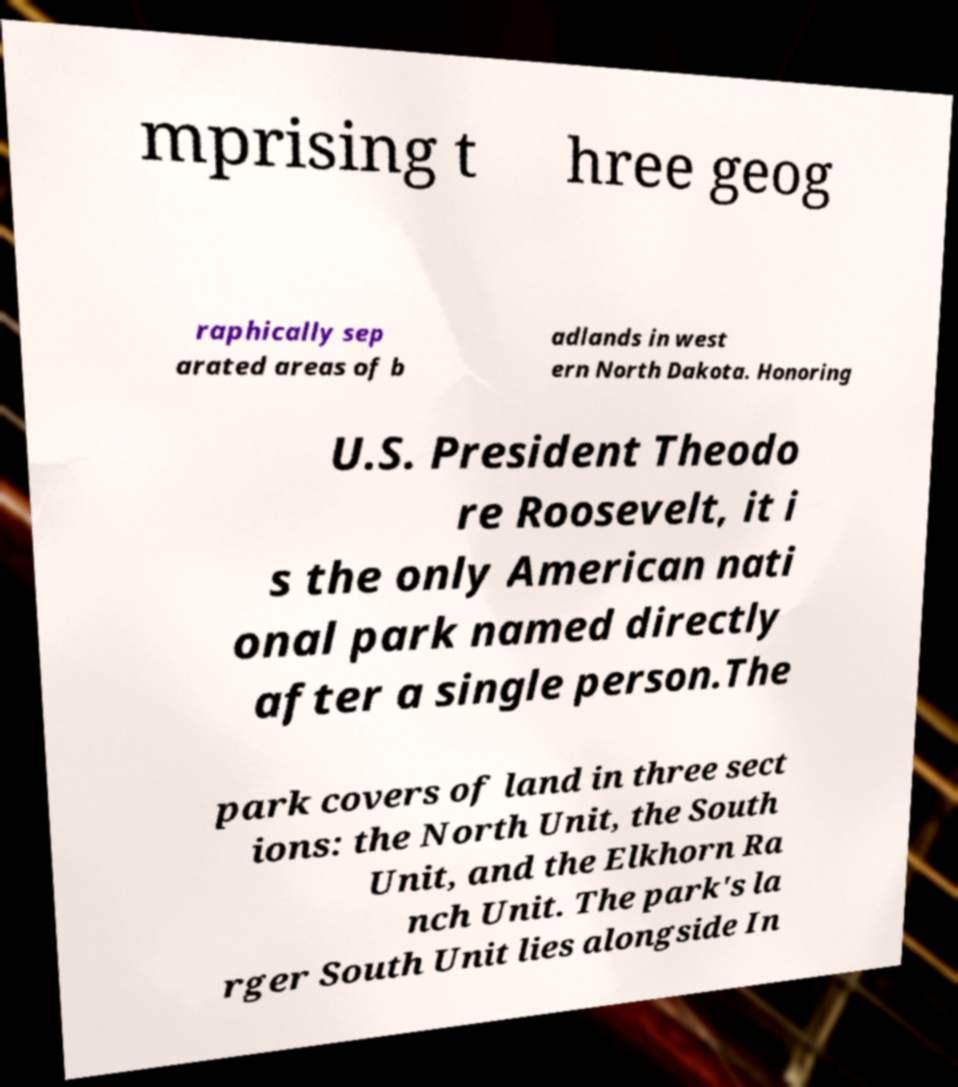Could you extract and type out the text from this image? mprising t hree geog raphically sep arated areas of b adlands in west ern North Dakota. Honoring U.S. President Theodo re Roosevelt, it i s the only American nati onal park named directly after a single person.The park covers of land in three sect ions: the North Unit, the South Unit, and the Elkhorn Ra nch Unit. The park's la rger South Unit lies alongside In 